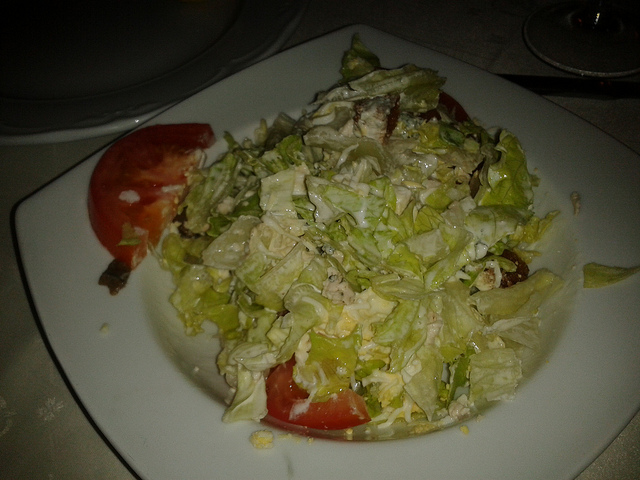<image>Is visual acuity promoted by this dish? It's ambiguous whether this dish promotes visual acuity. Where is the corn? It is not known where the corn is. It can be either in the salad or not present at all. Where is the corn? The corn is not seen in the image. It is nowhere to be found. Is visual acuity promoted by this dish? I don't know if visual acuity is promoted by this dish. It can be both promoted or not promoted. 